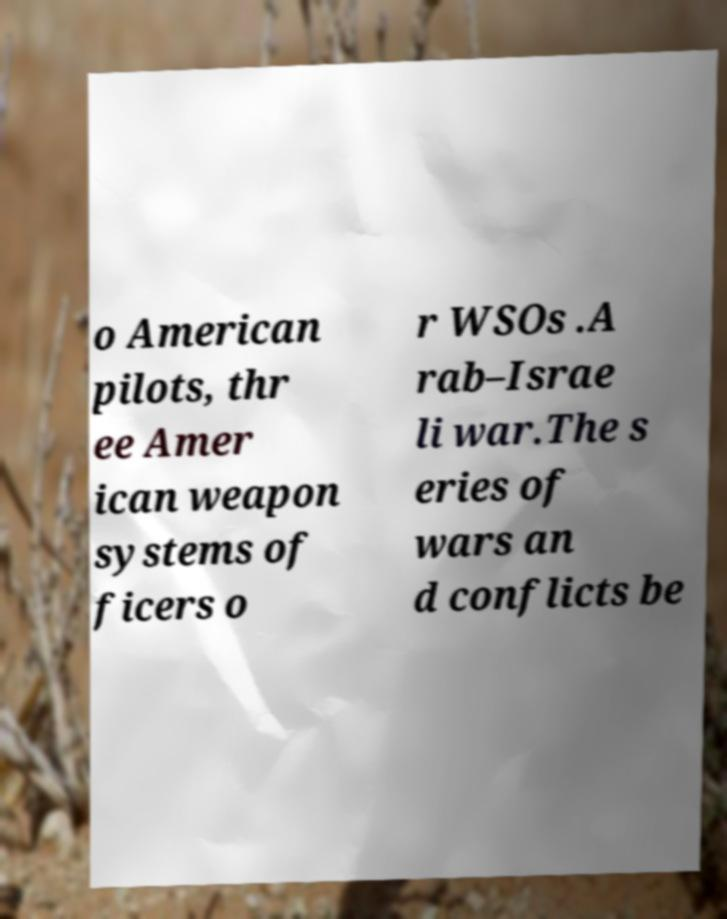For documentation purposes, I need the text within this image transcribed. Could you provide that? o American pilots, thr ee Amer ican weapon systems of ficers o r WSOs .A rab–Israe li war.The s eries of wars an d conflicts be 